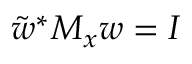Convert formula to latex. <formula><loc_0><loc_0><loc_500><loc_500>\tilde { w } ^ { * } M _ { x } w = I</formula> 